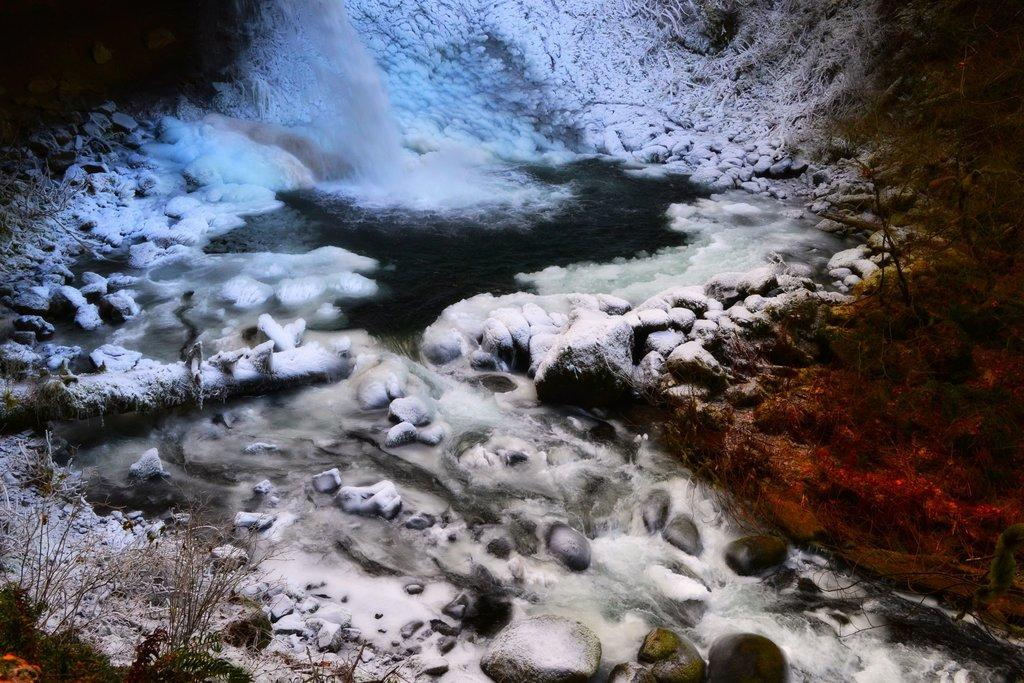What is one of the natural elements present in the image? There is ice in the image. What is another natural element present in the image? There is water in the image. What type of geological feature can be seen in the image? There are rocks in the image. What type of vegetation is present in the image? There are trees in the image. What is the opinion of the ice in the image? The ice in the image does not have an opinion, as it is an inanimate object. 